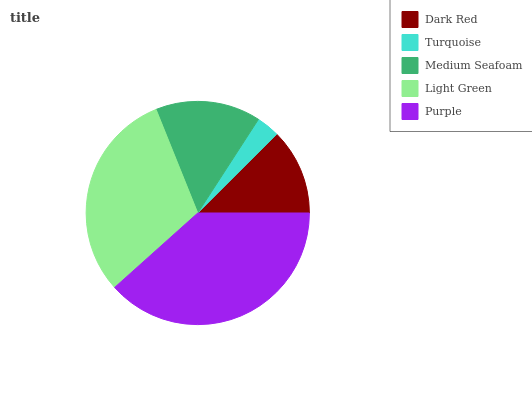Is Turquoise the minimum?
Answer yes or no. Yes. Is Purple the maximum?
Answer yes or no. Yes. Is Medium Seafoam the minimum?
Answer yes or no. No. Is Medium Seafoam the maximum?
Answer yes or no. No. Is Medium Seafoam greater than Turquoise?
Answer yes or no. Yes. Is Turquoise less than Medium Seafoam?
Answer yes or no. Yes. Is Turquoise greater than Medium Seafoam?
Answer yes or no. No. Is Medium Seafoam less than Turquoise?
Answer yes or no. No. Is Medium Seafoam the high median?
Answer yes or no. Yes. Is Medium Seafoam the low median?
Answer yes or no. Yes. Is Light Green the high median?
Answer yes or no. No. Is Dark Red the low median?
Answer yes or no. No. 